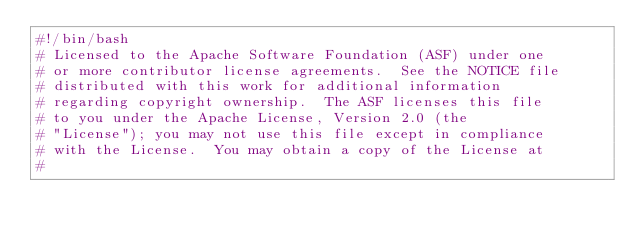<code> <loc_0><loc_0><loc_500><loc_500><_Bash_>#!/bin/bash
# Licensed to the Apache Software Foundation (ASF) under one
# or more contributor license agreements.  See the NOTICE file
# distributed with this work for additional information
# regarding copyright ownership.  The ASF licenses this file
# to you under the Apache License, Version 2.0 (the
# "License"); you may not use this file except in compliance
# with the License.  You may obtain a copy of the License at
#</code> 